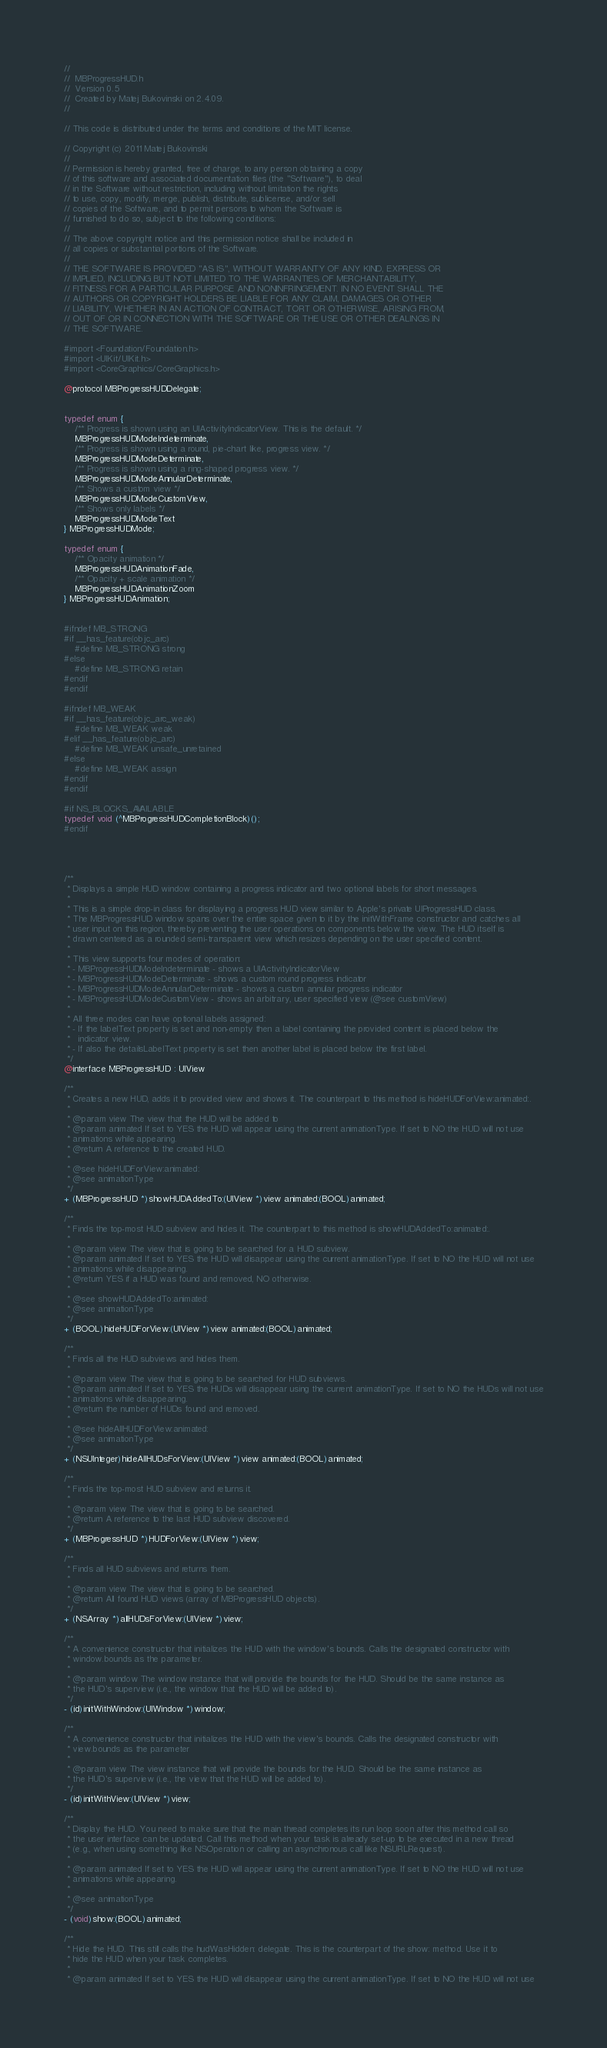Convert code to text. <code><loc_0><loc_0><loc_500><loc_500><_C_>//
//  MBProgressHUD.h
//  Version 0.5
//  Created by Matej Bukovinski on 2.4.09.
//

// This code is distributed under the terms and conditions of the MIT license. 

// Copyright (c) 2011 Matej Bukovinski
//
// Permission is hereby granted, free of charge, to any person obtaining a copy
// of this software and associated documentation files (the "Software"), to deal
// in the Software without restriction, including without limitation the rights
// to use, copy, modify, merge, publish, distribute, sublicense, and/or sell
// copies of the Software, and to permit persons to whom the Software is
// furnished to do so, subject to the following conditions:
//
// The above copyright notice and this permission notice shall be included in
// all copies or substantial portions of the Software.
//
// THE SOFTWARE IS PROVIDED "AS IS", WITHOUT WARRANTY OF ANY KIND, EXPRESS OR
// IMPLIED, INCLUDING BUT NOT LIMITED TO THE WARRANTIES OF MERCHANTABILITY,
// FITNESS FOR A PARTICULAR PURPOSE AND NONINFRINGEMENT. IN NO EVENT SHALL THE
// AUTHORS OR COPYRIGHT HOLDERS BE LIABLE FOR ANY CLAIM, DAMAGES OR OTHER
// LIABILITY, WHETHER IN AN ACTION OF CONTRACT, TORT OR OTHERWISE, ARISING FROM,
// OUT OF OR IN CONNECTION WITH THE SOFTWARE OR THE USE OR OTHER DEALINGS IN
// THE SOFTWARE.

#import <Foundation/Foundation.h>
#import <UIKit/UIKit.h>
#import <CoreGraphics/CoreGraphics.h>

@protocol MBProgressHUDDelegate;


typedef enum {
	/** Progress is shown using an UIActivityIndicatorView. This is the default. */
	MBProgressHUDModeIndeterminate,
	/** Progress is shown using a round, pie-chart like, progress view. */
	MBProgressHUDModeDeterminate,
	/** Progress is shown using a ring-shaped progress view. */
	MBProgressHUDModeAnnularDeterminate,
	/** Shows a custom view */
	MBProgressHUDModeCustomView,
	/** Shows only labels */
	MBProgressHUDModeText
} MBProgressHUDMode;

typedef enum {
	/** Opacity animation */
	MBProgressHUDAnimationFade,
	/** Opacity + scale animation */
	MBProgressHUDAnimationZoom
} MBProgressHUDAnimation;


#ifndef MB_STRONG
#if __has_feature(objc_arc)
	#define MB_STRONG strong
#else
	#define MB_STRONG retain
#endif
#endif

#ifndef MB_WEAK
#if __has_feature(objc_arc_weak)
	#define MB_WEAK weak
#elif __has_feature(objc_arc)
	#define MB_WEAK unsafe_unretained
#else
	#define MB_WEAK assign
#endif
#endif

#if NS_BLOCKS_AVAILABLE
typedef void (^MBProgressHUDCompletionBlock)();
#endif




/** 
 * Displays a simple HUD window containing a progress indicator and two optional labels for short messages.
 *
 * This is a simple drop-in class for displaying a progress HUD view similar to Apple's private UIProgressHUD class.
 * The MBProgressHUD window spans over the entire space given to it by the initWithFrame constructor and catches all
 * user input on this region, thereby preventing the user operations on components below the view. The HUD itself is
 * drawn centered as a rounded semi-transparent view which resizes depending on the user specified content.
 *
 * This view supports four modes of operation:
 * - MBProgressHUDModeIndeterminate - shows a UIActivityIndicatorView
 * - MBProgressHUDModeDeterminate - shows a custom round progress indicator
 * - MBProgressHUDModeAnnularDeterminate - shows a custom annular progress indicator
 * - MBProgressHUDModeCustomView - shows an arbitrary, user specified view (@see customView)
 *
 * All three modes can have optional labels assigned:
 * - If the labelText property is set and non-empty then a label containing the provided content is placed below the
 *   indicator view.
 * - If also the detailsLabelText property is set then another label is placed below the first label.
 */
@interface MBProgressHUD : UIView

/**
 * Creates a new HUD, adds it to provided view and shows it. The counterpart to this method is hideHUDForView:animated:.
 * 
 * @param view The view that the HUD will be added to
 * @param animated If set to YES the HUD will appear using the current animationType. If set to NO the HUD will not use
 * animations while appearing.
 * @return A reference to the created HUD.
 *
 * @see hideHUDForView:animated:
 * @see animationType
 */
+ (MBProgressHUD *)showHUDAddedTo:(UIView *)view animated:(BOOL)animated;

/**
 * Finds the top-most HUD subview and hides it. The counterpart to this method is showHUDAddedTo:animated:.
 *
 * @param view The view that is going to be searched for a HUD subview.
 * @param animated If set to YES the HUD will disappear using the current animationType. If set to NO the HUD will not use
 * animations while disappearing.
 * @return YES if a HUD was found and removed, NO otherwise. 
 *
 * @see showHUDAddedTo:animated:
 * @see animationType
 */
+ (BOOL)hideHUDForView:(UIView *)view animated:(BOOL)animated;

/**
 * Finds all the HUD subviews and hides them. 
 *
 * @param view The view that is going to be searched for HUD subviews.
 * @param animated If set to YES the HUDs will disappear using the current animationType. If set to NO the HUDs will not use
 * animations while disappearing.
 * @return the number of HUDs found and removed.
 *
 * @see hideAllHUDForView:animated:
 * @see animationType
 */
+ (NSUInteger)hideAllHUDsForView:(UIView *)view animated:(BOOL)animated;

/**
 * Finds the top-most HUD subview and returns it. 
 *
 * @param view The view that is going to be searched.
 * @return A reference to the last HUD subview discovered.
 */
+ (MBProgressHUD *)HUDForView:(UIView *)view;

/**
 * Finds all HUD subviews and returns them.
 *
 * @param view The view that is going to be searched.
 * @return All found HUD views (array of MBProgressHUD objects).
 */
+ (NSArray *)allHUDsForView:(UIView *)view;

/**
 * A convenience constructor that initializes the HUD with the window's bounds. Calls the designated constructor with
 * window.bounds as the parameter.
 *
 * @param window The window instance that will provide the bounds for the HUD. Should be the same instance as
 * the HUD's superview (i.e., the window that the HUD will be added to).
 */
- (id)initWithWindow:(UIWindow *)window;

/**
 * A convenience constructor that initializes the HUD with the view's bounds. Calls the designated constructor with
 * view.bounds as the parameter
 *
 * @param view The view instance that will provide the bounds for the HUD. Should be the same instance as
 * the HUD's superview (i.e., the view that the HUD will be added to).
 */
- (id)initWithView:(UIView *)view;

/** 
 * Display the HUD. You need to make sure that the main thread completes its run loop soon after this method call so
 * the user interface can be updated. Call this method when your task is already set-up to be executed in a new thread
 * (e.g., when using something like NSOperation or calling an asynchronous call like NSURLRequest).
 *
 * @param animated If set to YES the HUD will appear using the current animationType. If set to NO the HUD will not use
 * animations while appearing.
 *
 * @see animationType
 */
- (void)show:(BOOL)animated;

/** 
 * Hide the HUD. This still calls the hudWasHidden: delegate. This is the counterpart of the show: method. Use it to
 * hide the HUD when your task completes.
 *
 * @param animated If set to YES the HUD will disappear using the current animationType. If set to NO the HUD will not use</code> 